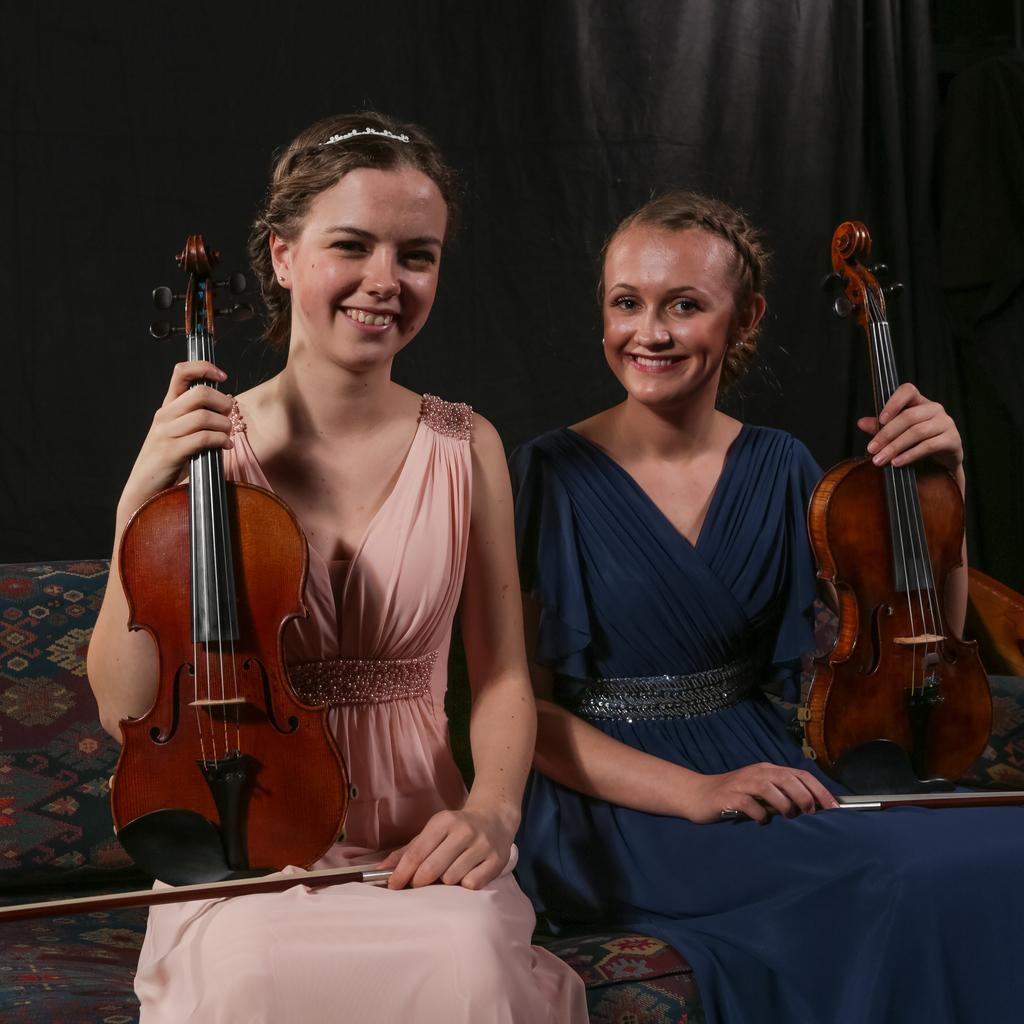How many people are in the image? There are two women in the image. What are the women doing in the image? The women are smiling and holding musical instruments. Where are the women sitting in the image? The women are sitting on a couch. What type of flowers are the women holding in the image? There are no flowers present in the image; the women are holding musical instruments. 